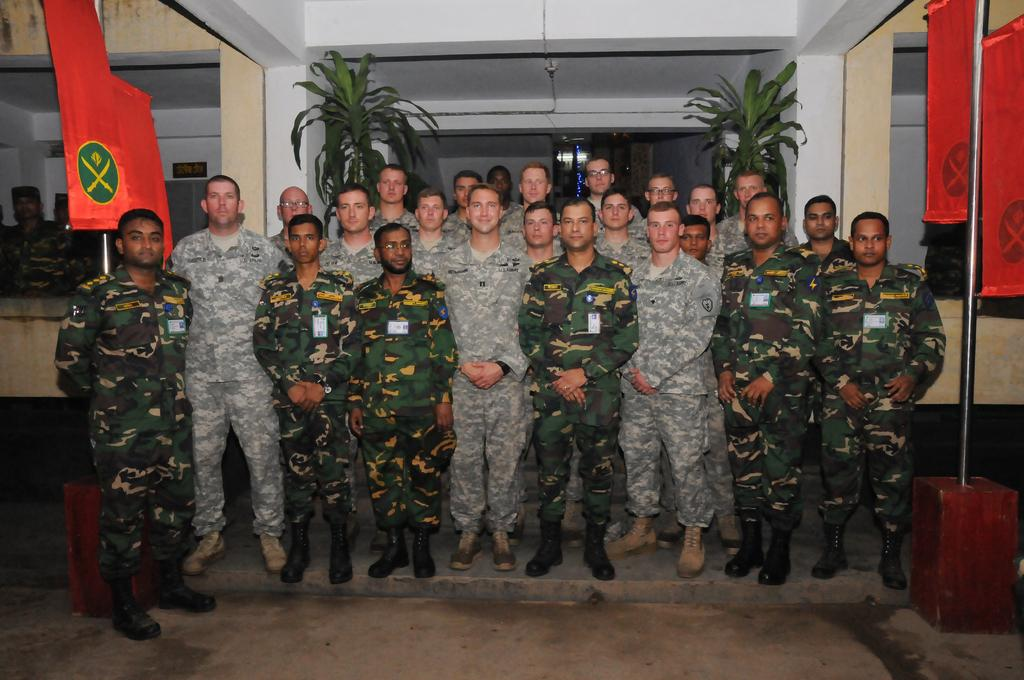What are the persons in the image wearing? The persons in the image are wearing uniforms. What are the persons in the image doing? The persons are standing. What can be seen attached to the poles in the image? There are flags in the image. What color are the flags in the image? The flags are red in color. What type of vegetation is present in the image? There are plants in the image. What type of structure is visible in the image? There is a building in the image. What type of bomb can be seen in the image? There is no bomb present in the image. What type of learning material can be seen in the image? There is no learning material present in the image. 